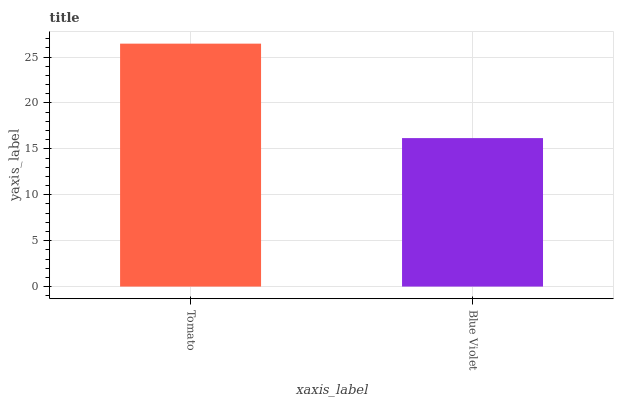Is Tomato the maximum?
Answer yes or no. Yes. Is Blue Violet the maximum?
Answer yes or no. No. Is Tomato greater than Blue Violet?
Answer yes or no. Yes. Is Blue Violet less than Tomato?
Answer yes or no. Yes. Is Blue Violet greater than Tomato?
Answer yes or no. No. Is Tomato less than Blue Violet?
Answer yes or no. No. Is Tomato the high median?
Answer yes or no. Yes. Is Blue Violet the low median?
Answer yes or no. Yes. Is Blue Violet the high median?
Answer yes or no. No. Is Tomato the low median?
Answer yes or no. No. 